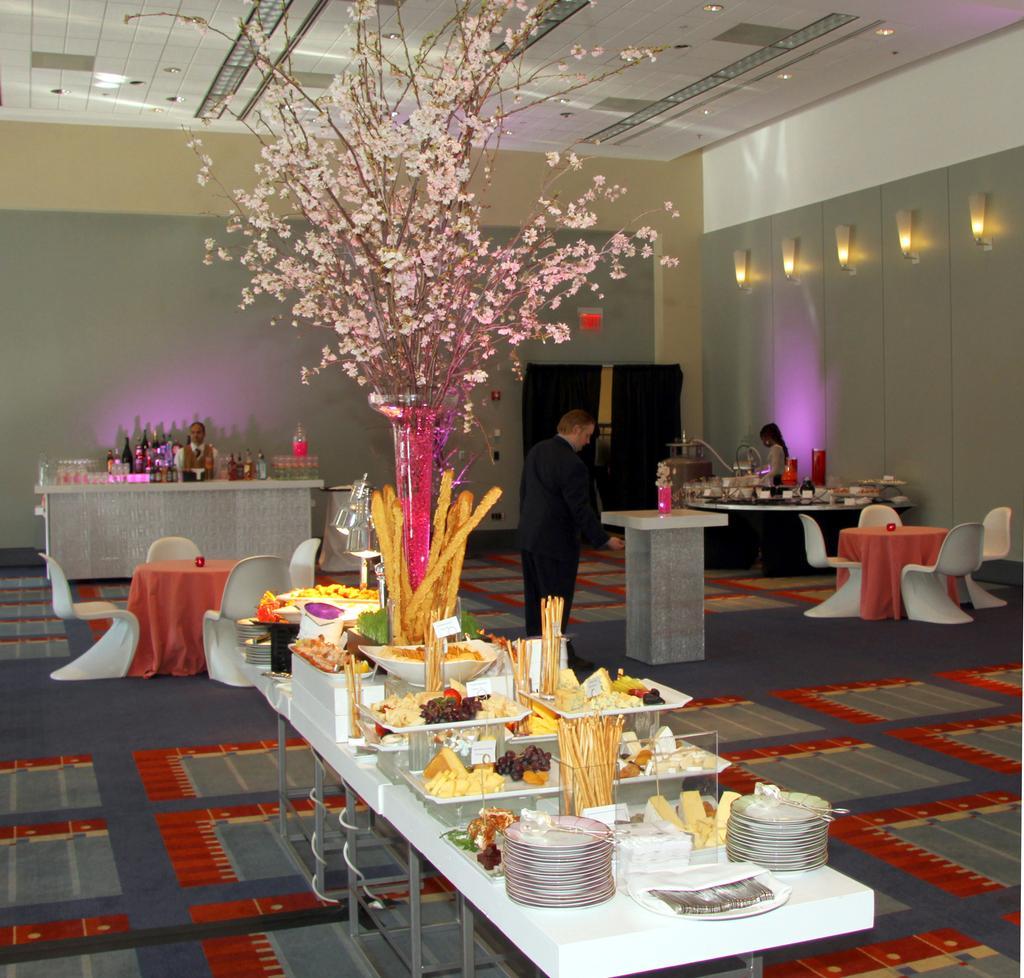Please provide a concise description of this image. On the table we can see many plates, trays, tissue papers, box, chopsticks, grapes, fruits and other food items. Here we can see a plant which is on the red color glass pot. Here we can see a man who is standing near to the candle. On the left we can see four chairs near to the table which is covered by cloth. On the background there is a man who is standing near to the desk. On the desk we can see wine bottles and other bottles. On the right we can see a woman who is standing near to the table. Here we can see five lights on the wall. On the top there is ceiling. 